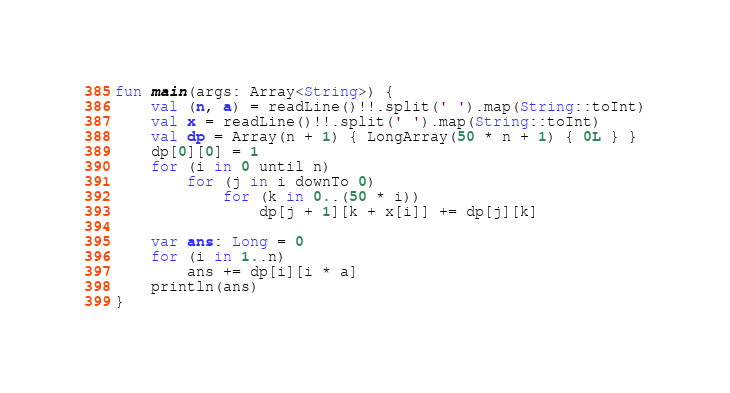<code> <loc_0><loc_0><loc_500><loc_500><_Kotlin_>fun main(args: Array<String>) {
    val (n, a) = readLine()!!.split(' ').map(String::toInt)
    val x = readLine()!!.split(' ').map(String::toInt)
    val dp = Array(n + 1) { LongArray(50 * n + 1) { 0L } }
    dp[0][0] = 1
    for (i in 0 until n)
        for (j in i downTo 0)
            for (k in 0..(50 * i))
                dp[j + 1][k + x[i]] += dp[j][k]

    var ans: Long = 0
    for (i in 1..n)
        ans += dp[i][i * a]
    println(ans)
}</code> 